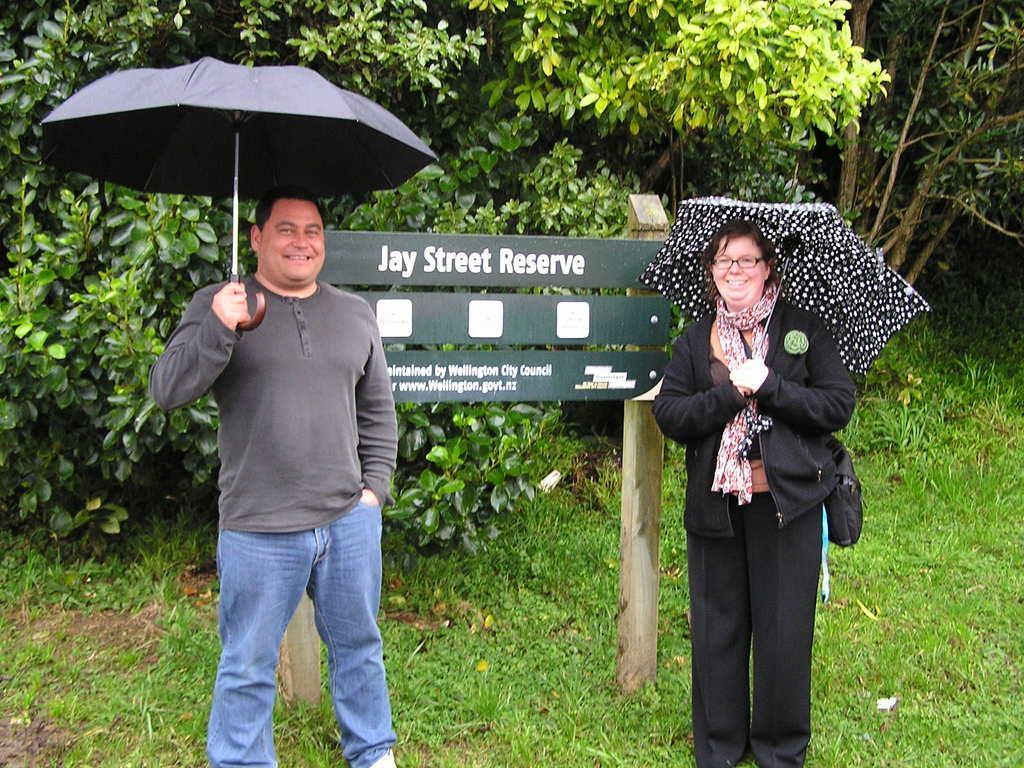Can you describe this image briefly? As we can see in the image there are two persons holding umbrellas and there are trees. The man standing on the left side is wearing grey color t shirt and the woman on the right side is wearing black color dress. There is grass and sign board. 